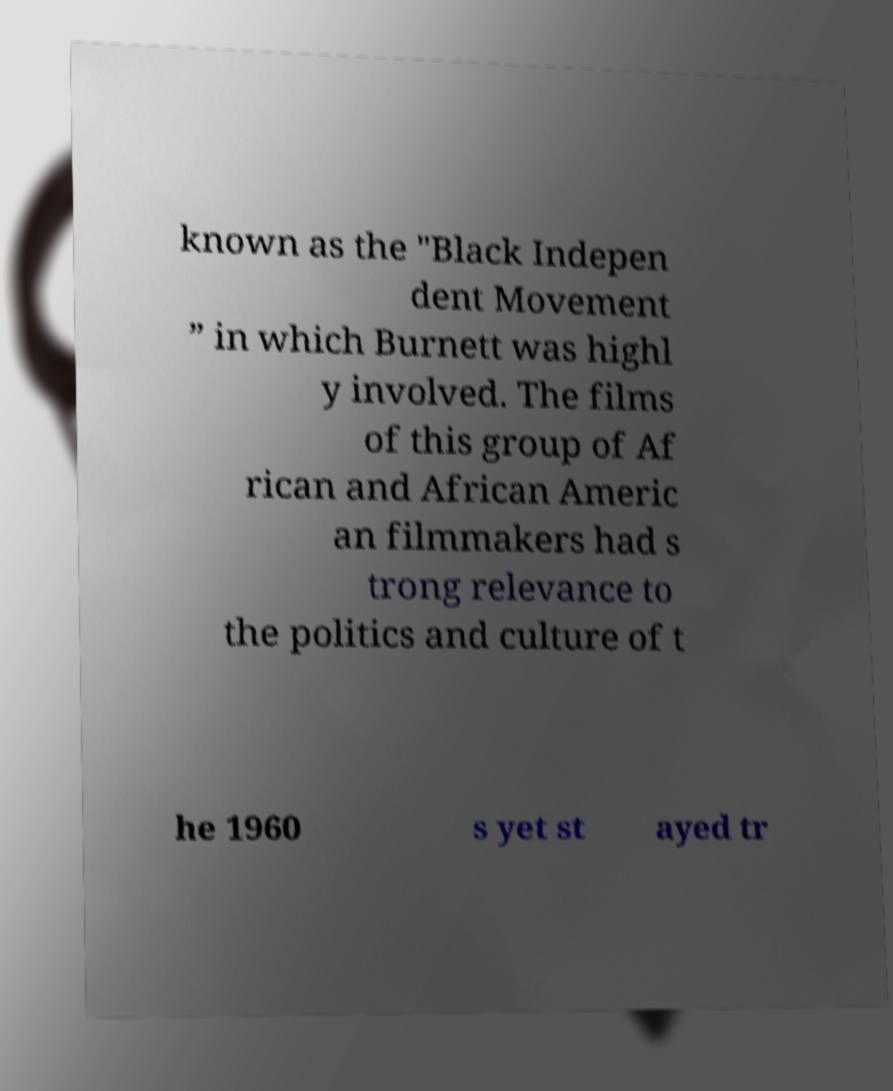Could you assist in decoding the text presented in this image and type it out clearly? known as the "Black Indepen dent Movement ” in which Burnett was highl y involved. The films of this group of Af rican and African Americ an filmmakers had s trong relevance to the politics and culture of t he 1960 s yet st ayed tr 